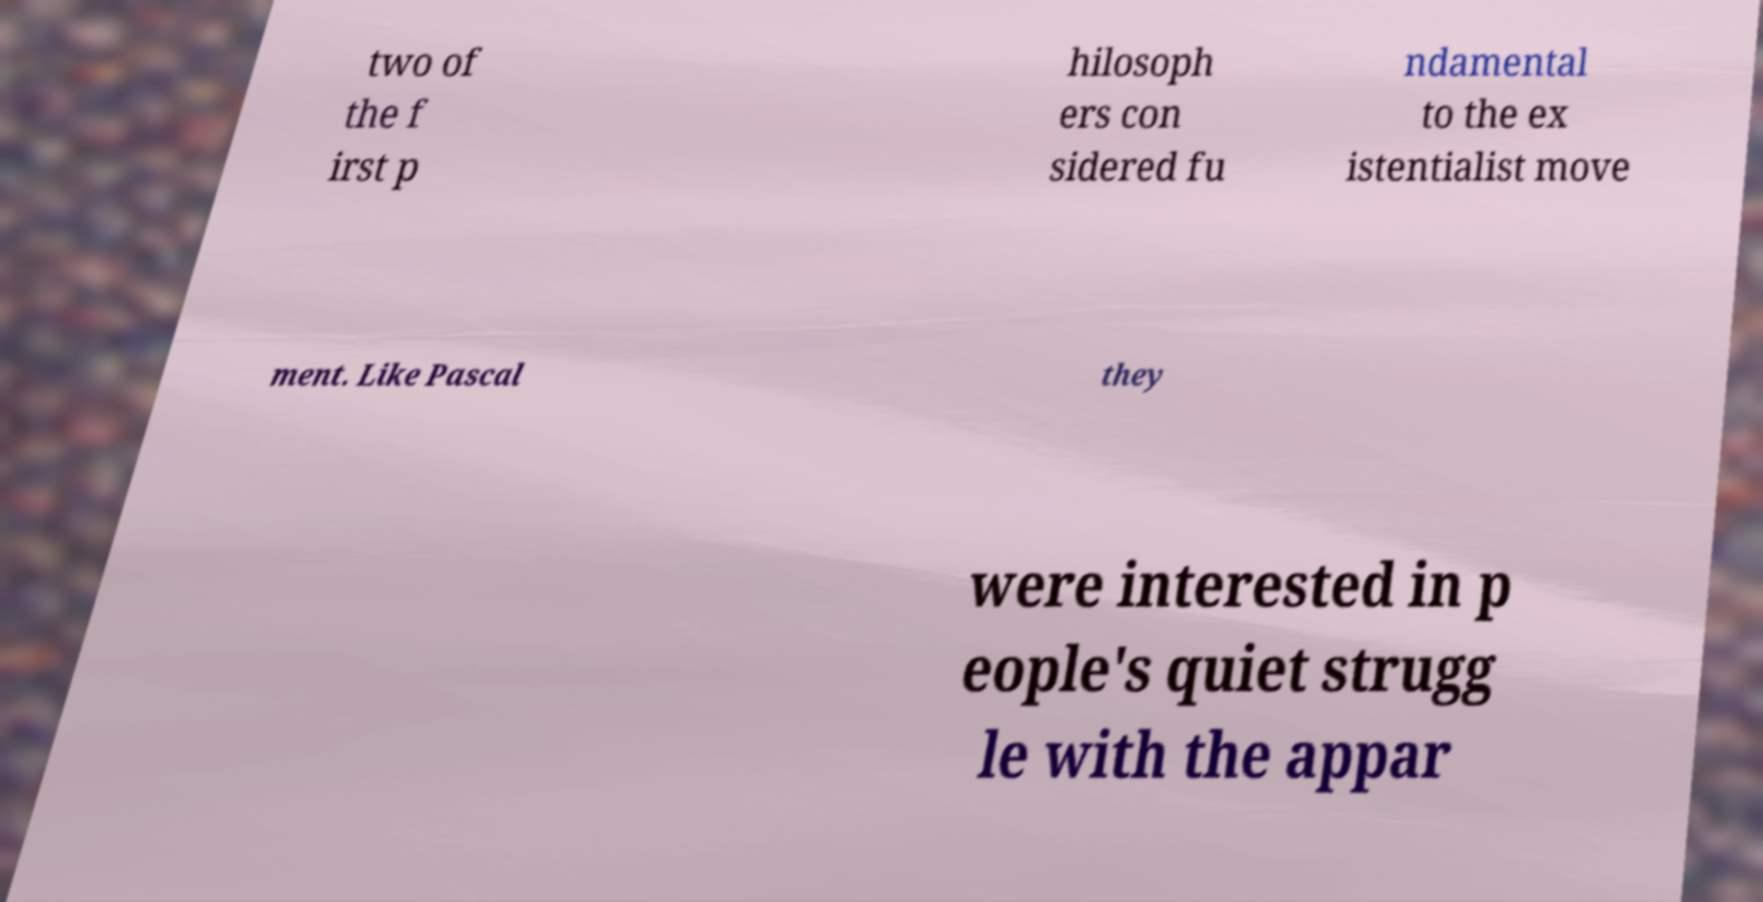There's text embedded in this image that I need extracted. Can you transcribe it verbatim? two of the f irst p hilosoph ers con sidered fu ndamental to the ex istentialist move ment. Like Pascal they were interested in p eople's quiet strugg le with the appar 